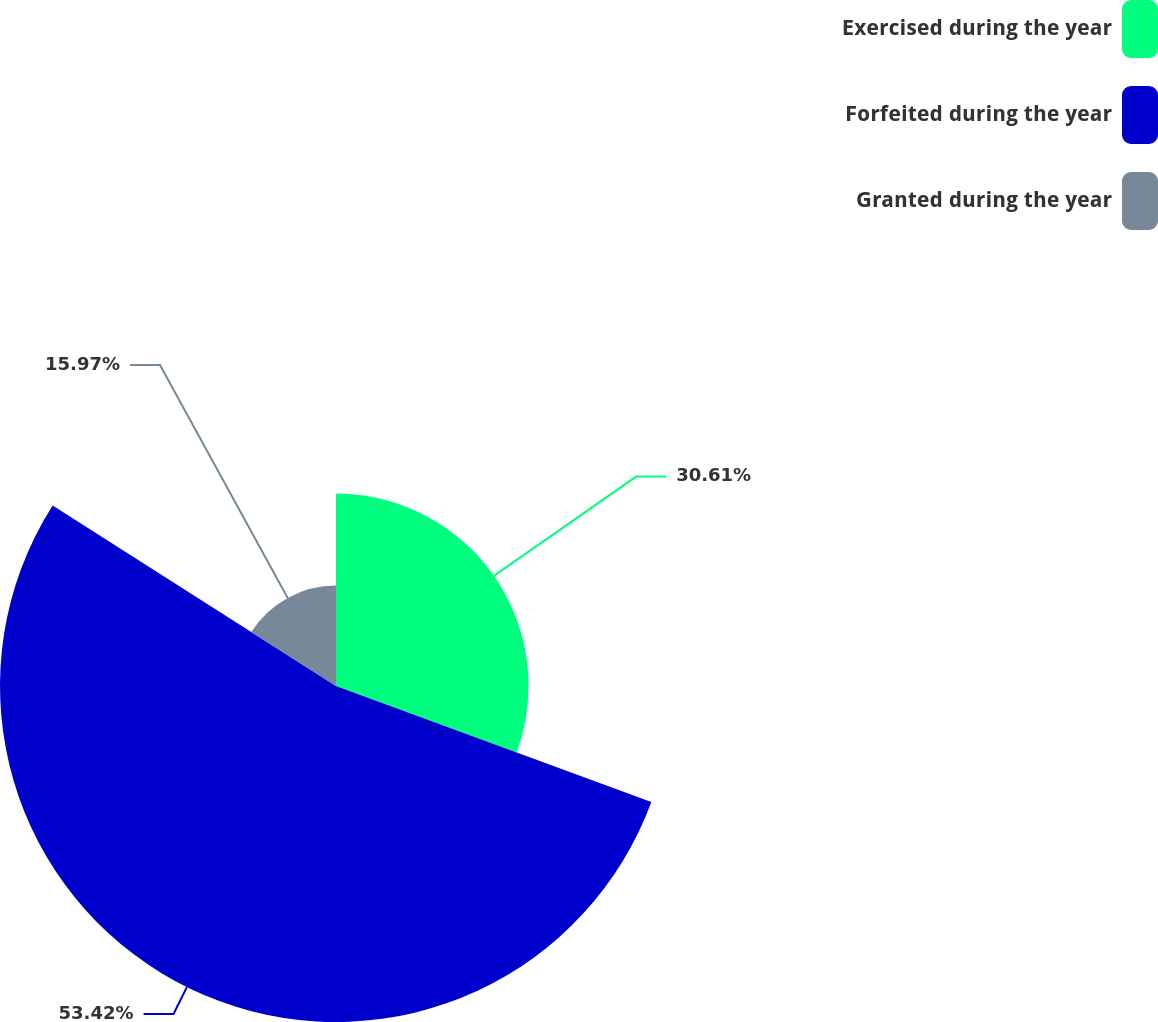<chart> <loc_0><loc_0><loc_500><loc_500><pie_chart><fcel>Exercised during the year<fcel>Forfeited during the year<fcel>Granted during the year<nl><fcel>30.61%<fcel>53.42%<fcel>15.97%<nl></chart> 